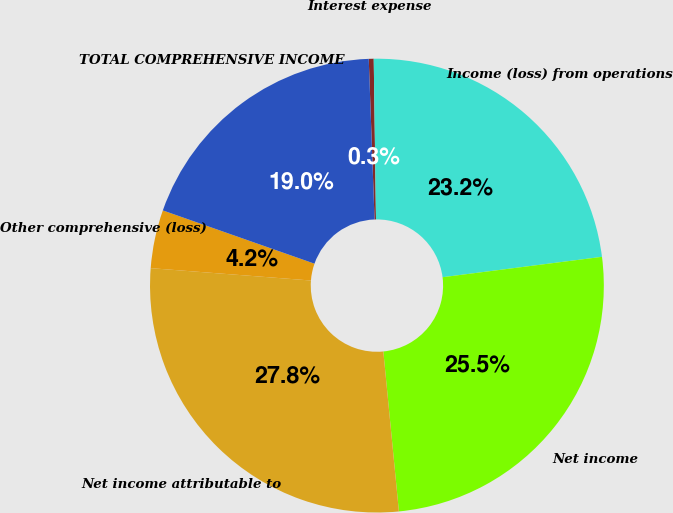Convert chart to OTSL. <chart><loc_0><loc_0><loc_500><loc_500><pie_chart><fcel>Interest expense<fcel>Income (loss) from operations<fcel>Net income<fcel>Net income attributable to<fcel>Other comprehensive (loss)<fcel>TOTAL COMPREHENSIVE INCOME<nl><fcel>0.35%<fcel>23.2%<fcel>25.48%<fcel>27.77%<fcel>4.15%<fcel>19.05%<nl></chart> 